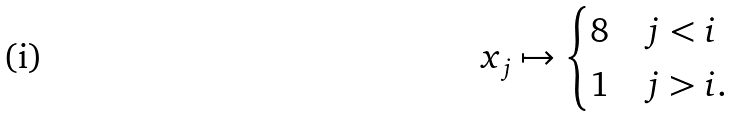Convert formula to latex. <formula><loc_0><loc_0><loc_500><loc_500>x _ { j } \mapsto \begin{cases} 8 & j < i \\ 1 & j > i . \end{cases}</formula> 